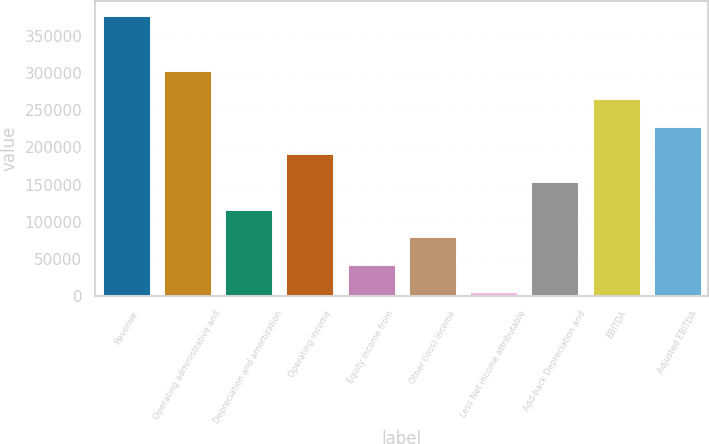<chart> <loc_0><loc_0><loc_500><loc_500><bar_chart><fcel>Revenue<fcel>Operating administrative and<fcel>Depreciation and amortization<fcel>Operating income<fcel>Equity income from<fcel>Other (loss) income<fcel>Less Net income attributable<fcel>Add-back Depreciation and<fcel>EBITDA<fcel>Adjusted EBITDA<nl><fcel>377644<fcel>303371<fcel>117689<fcel>191962<fcel>43416.4<fcel>80552.8<fcel>6280<fcel>154826<fcel>266235<fcel>229098<nl></chart> 